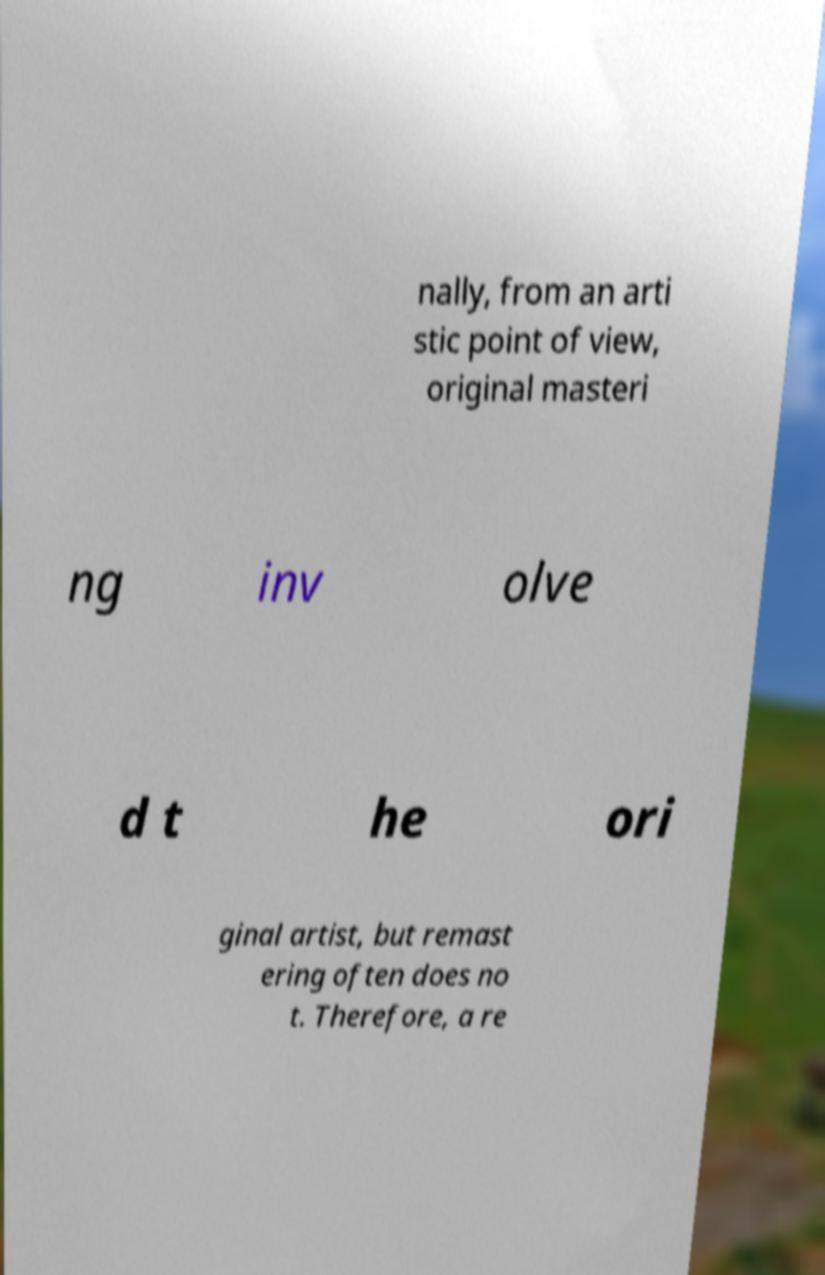Please identify and transcribe the text found in this image. nally, from an arti stic point of view, original masteri ng inv olve d t he ori ginal artist, but remast ering often does no t. Therefore, a re 